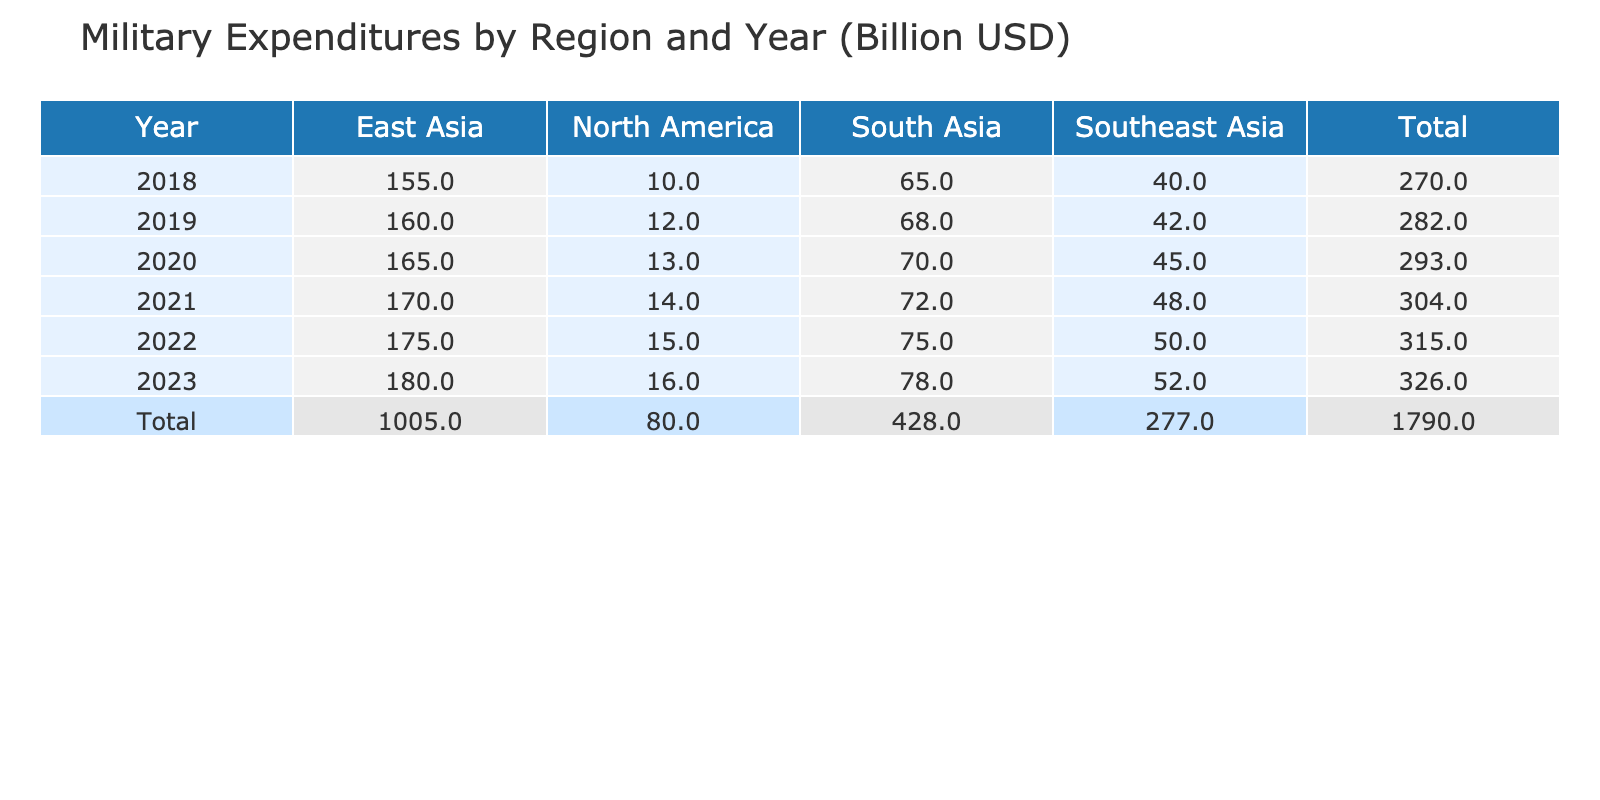What was the military expenditure of East Asia in 2021? According to the table, the expenditure for East Asia in 2021 is listed directly in the corresponding row, which shows a value of 170 billion USD.
Answer: 170 billion USD What is the military expenditure in North America for the year 2022? The table provides the specific expenditure for North America in 2022, which is shown in the row for that year, revealing a value of 15 billion USD.
Answer: 15 billion USD Which region saw the highest military expenditure increase from 2018 to 2023? We compare the military expenditures of each region between 2018 and 2023: East Asia increased from 155 billion USD to 180 billion USD (25 billion USD increase), Southeast Asia from 40 billion USD to 52 billion USD (12 billion USD increase), South Asia from 65 billion USD to 78 billion USD (13 billion USD increase), and North America from 10 billion USD to 16 billion USD (6 billion USD increase). East Asia had the largest increase of 25 billion USD.
Answer: East Asia What is the total military expenditure for Southeast Asia from 2019 to 2023? We need to sum the expenditures for each year from 2019 to 2023 for Southeast Asia: 42 + 45 + 48 + 50 + 52 = 237 billion USD.
Answer: 237 billion USD Is the military expenditure of South Asia in 2020 higher than that of North America in the same year? In the table, South Asia’s expenditure in 2020 is 70 billion USD, and North America’s expenditure for the same year is 13 billion USD. Since 70 billion USD is greater than 13 billion USD, the answer is yes.
Answer: Yes What is the average military expenditure for East Asia from 2018 to 2023? To find the average, we first sum the expenditures from 2018 to 2023: 155 + 160 + 165 + 170 + 175 + 180 = 1105 billion USD. There are 6 data points, so we divide 1105 by 6, yielding an average of approximately 184.17 billion USD when rounded to two decimal places.
Answer: 184.17 billion USD What was the total military expenditure across all regions in 2020? We need to add the expenditures for all regions in 2020 from the table: 165 (East Asia) + 45 (Southeast Asia) + 70 (South Asia) + 13 (North America) = 293 billion USD. This total represents military spending across all examined regions for that year.
Answer: 293 billion USD In which year did South Asia have a military expenditure equal to or greater than that of North America? On examining the data, for every year South Asia's expenditures were higher than North America: in every entry for South Asia (65, 68, 70, 72, 75, 78 billion USD) exceed those of North America (10, 12, 13, 14, 15, 16 billion USD). Therefore, the answer is all years from 2018 to 2023.
Answer: All years from 2018 to 2023 